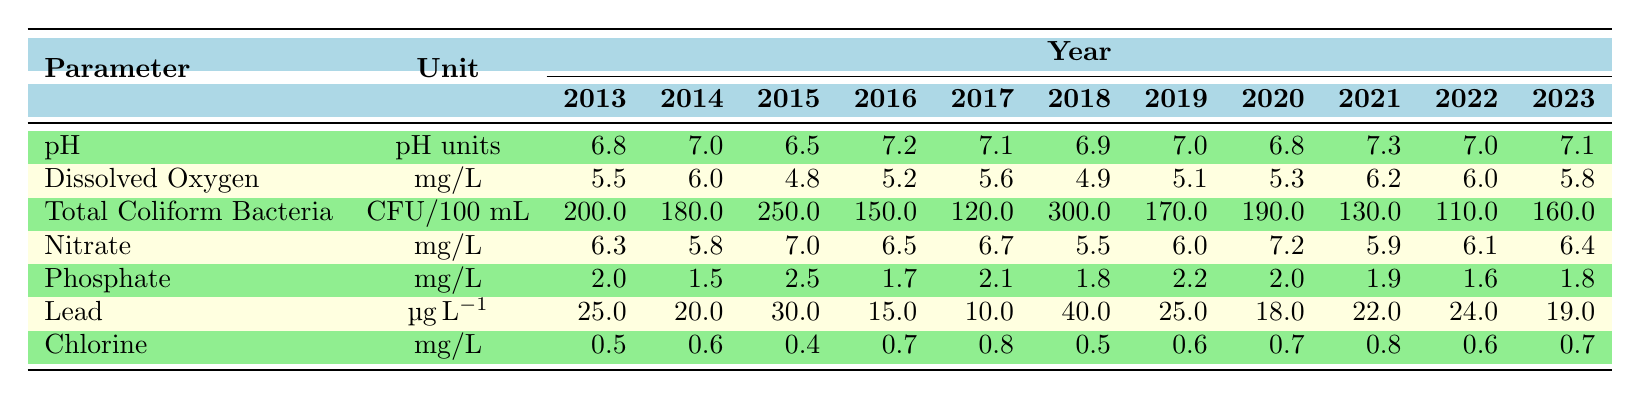What is the pH value in 2021? The table shows the pH values as follows for 2021: 7.3.
Answer: 7.3 What was the maximum level of Total Coliform Bacteria recorded in the data? The maximum value in the Total Coliform Bacteria row is 300 CFU/100 mL, which occurred in 2018.
Answer: 300 CFU/100 mL Is the average Dissolved Oxygen level over the entire period above 5 mg/L? To find the average, add each year's values from 2013 to 2023 and divide by the number of years (11). The total is (5.5 + 6.0 + 4.8 + 5.2 + 5.6 + 4.9 + 5.1 + 5.3 + 6.2 + 6.0 + 5.8) = 60.4, and the average is 60.4 / 11 ≈ 5.49, which is above 5.
Answer: Yes In which year was the Lead concentration at its highest? By examining the Lead row, the highest value is 40 µg/L, which was recorded in 2018.
Answer: 2018 How did the average Nitrate levels change from 2013 to 2023? First, calculate the average for the years 2013-2023. The values are 6.3, 5.8, 7.0, 6.5, 6.7, 5.5, 6.0, 7.2, 5.9, 6.1, and 6.4. The sum is 68.0, and the average is 68.0 / 11 ≈ 6.18. Notably, the Nitrate levels peaked in 2015 at 7.0 and decreased to 5.5 in 2018 before rising again in subsequent years, reflecting some fluctuations.
Answer: The average changed from 6.3 to 6.4, with fluctuations observed Did the Phosphate levels ever drop below 2 mg/L? By checking the Phosphate row, the lowest recorded value is 1.5 mg/L in 2014.
Answer: Yes What was the trend in Chlorine levels from 2013 to 2023? Analyzing the Chlorine row, the levels fluctuated slightly: starting at 0.5 mg/L in 2013, peaking at 0.8 mg/L in 2017 and 2021, before dipping back to 0.6 mg/L in 2022 and ending at 0.7 mg/L in 2023. Thus, there is a slight increase overall despite fluctuations.
Answer: Fluctuating increase overall What can we say about the trend of Total Coliform Bacteria from 2013 to 2023? Observing the Total Coliform Bacteria values, there is a noticeable decline from 200 CFU/100 mL in 2013 to a low of 110 CFU/100 mL in 2022, with a slight increase to 160 CFU/100 mL in 2023. The overall trend indicates a gradual improvement in water quality over most years.
Answer: Gradual improvement with slight increase in 2023 